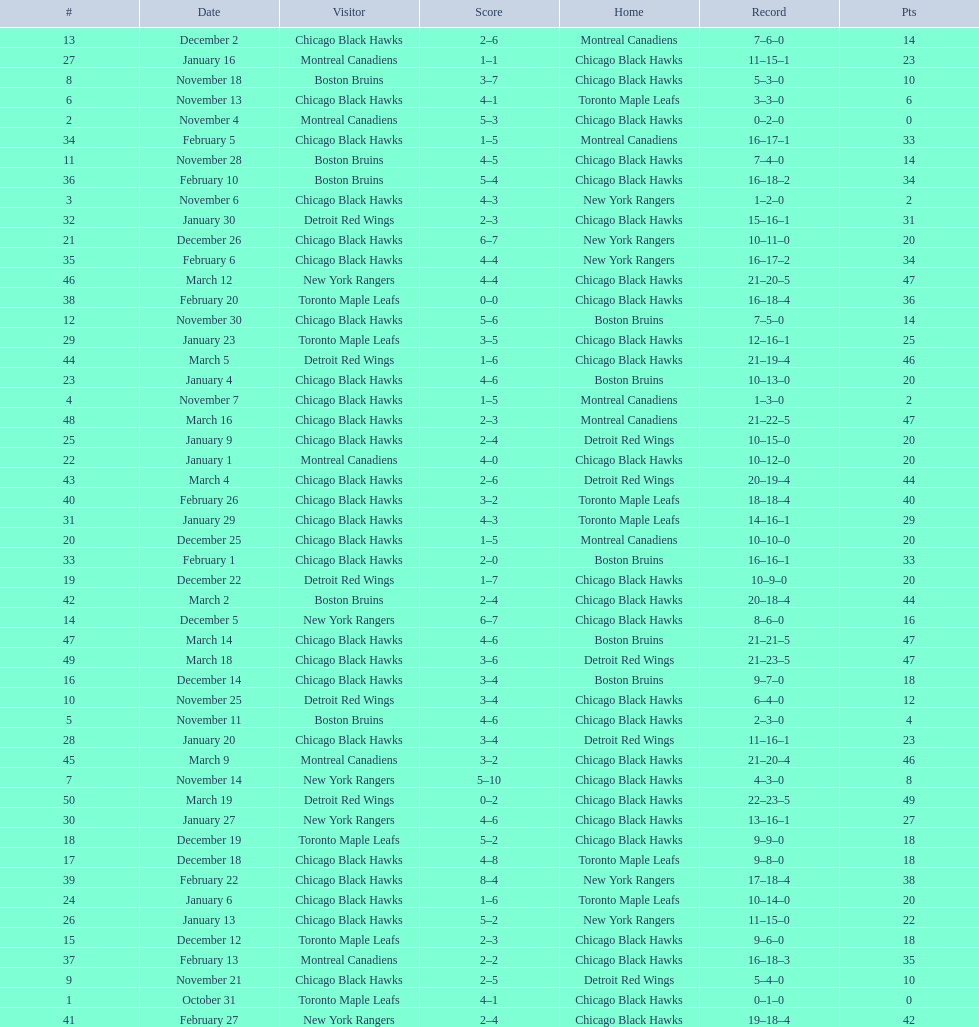What was the total amount of points scored on november 4th? 8. 